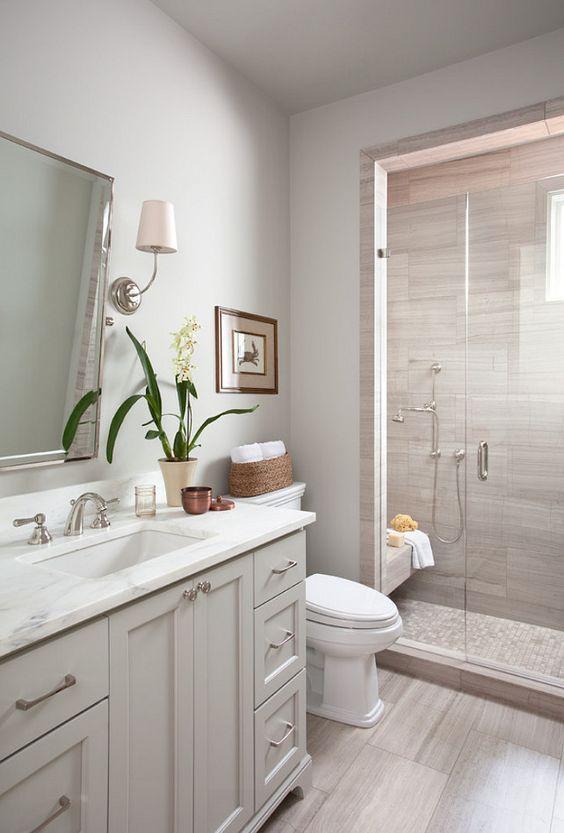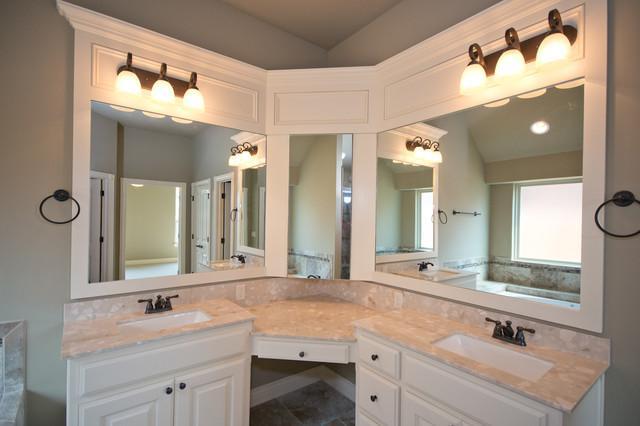The first image is the image on the left, the second image is the image on the right. Given the left and right images, does the statement "Exactly one bathroom vanity unit is wrapped around a wall." hold true? Answer yes or no. Yes. The first image is the image on the left, the second image is the image on the right. Considering the images on both sides, is "Both images have different wall colors and there is a stand alone bath tub in one of them." valid? Answer yes or no. No. 